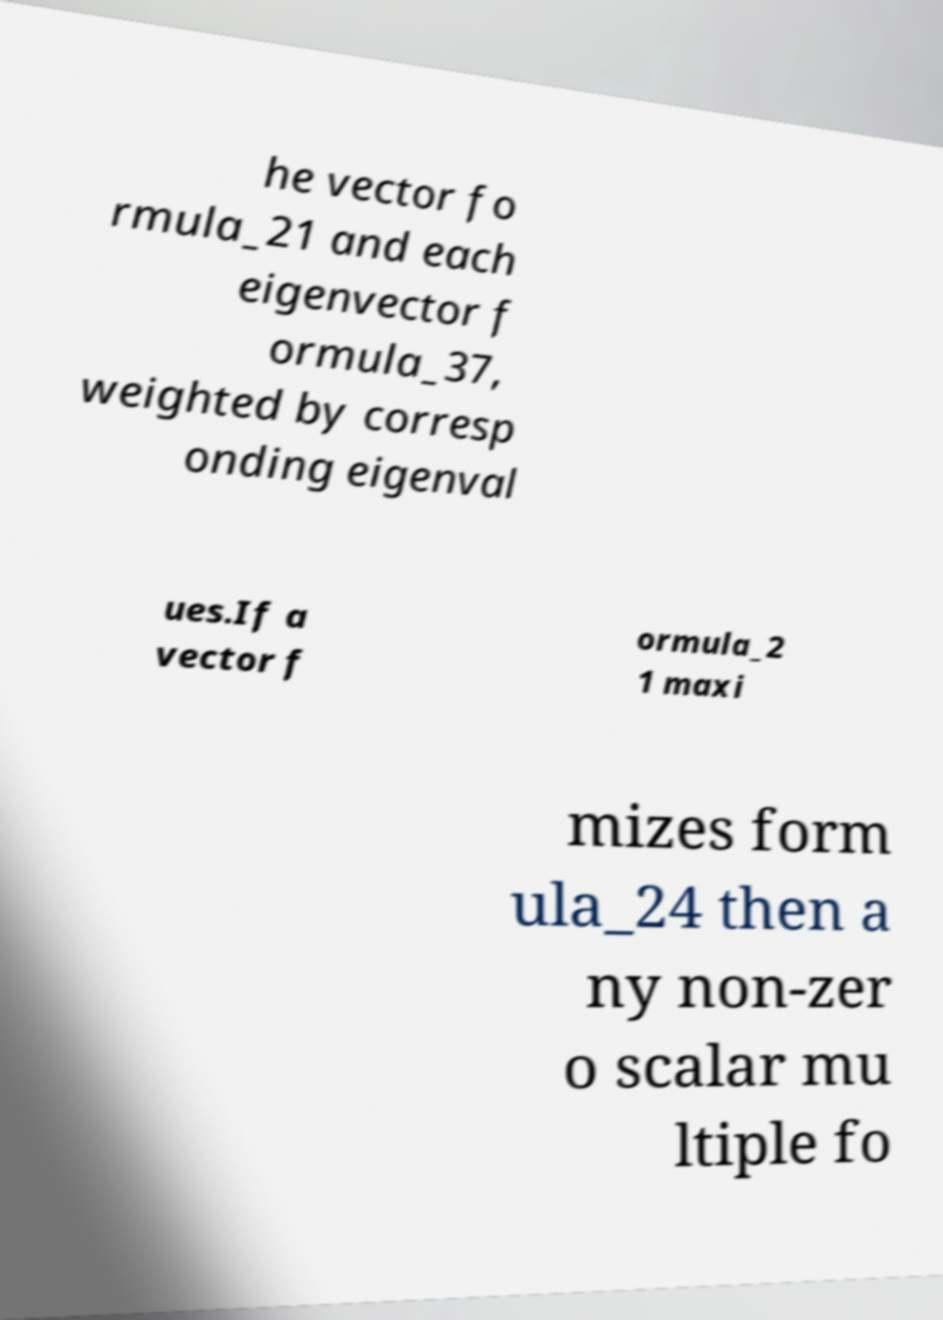Please identify and transcribe the text found in this image. he vector fo rmula_21 and each eigenvector f ormula_37, weighted by corresp onding eigenval ues.If a vector f ormula_2 1 maxi mizes form ula_24 then a ny non-zer o scalar mu ltiple fo 